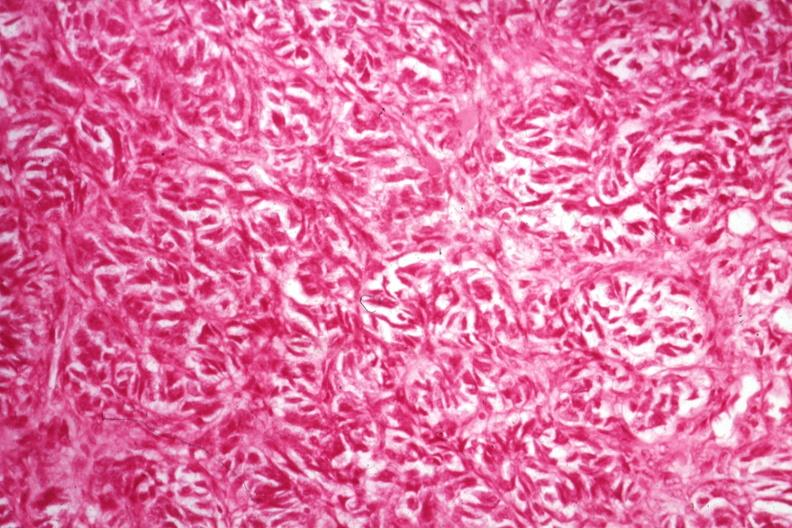s leg present?
Answer the question using a single word or phrase. No 